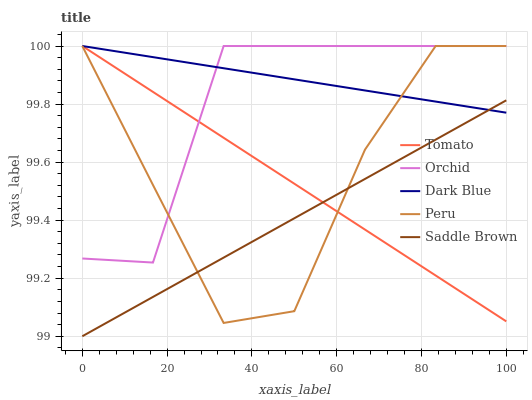Does Saddle Brown have the minimum area under the curve?
Answer yes or no. Yes. Does Dark Blue have the maximum area under the curve?
Answer yes or no. Yes. Does Dark Blue have the minimum area under the curve?
Answer yes or no. No. Does Saddle Brown have the maximum area under the curve?
Answer yes or no. No. Is Dark Blue the smoothest?
Answer yes or no. Yes. Is Peru the roughest?
Answer yes or no. Yes. Is Saddle Brown the smoothest?
Answer yes or no. No. Is Saddle Brown the roughest?
Answer yes or no. No. Does Dark Blue have the lowest value?
Answer yes or no. No. Does Saddle Brown have the highest value?
Answer yes or no. No. Is Saddle Brown less than Orchid?
Answer yes or no. Yes. Is Orchid greater than Saddle Brown?
Answer yes or no. Yes. Does Saddle Brown intersect Orchid?
Answer yes or no. No. 